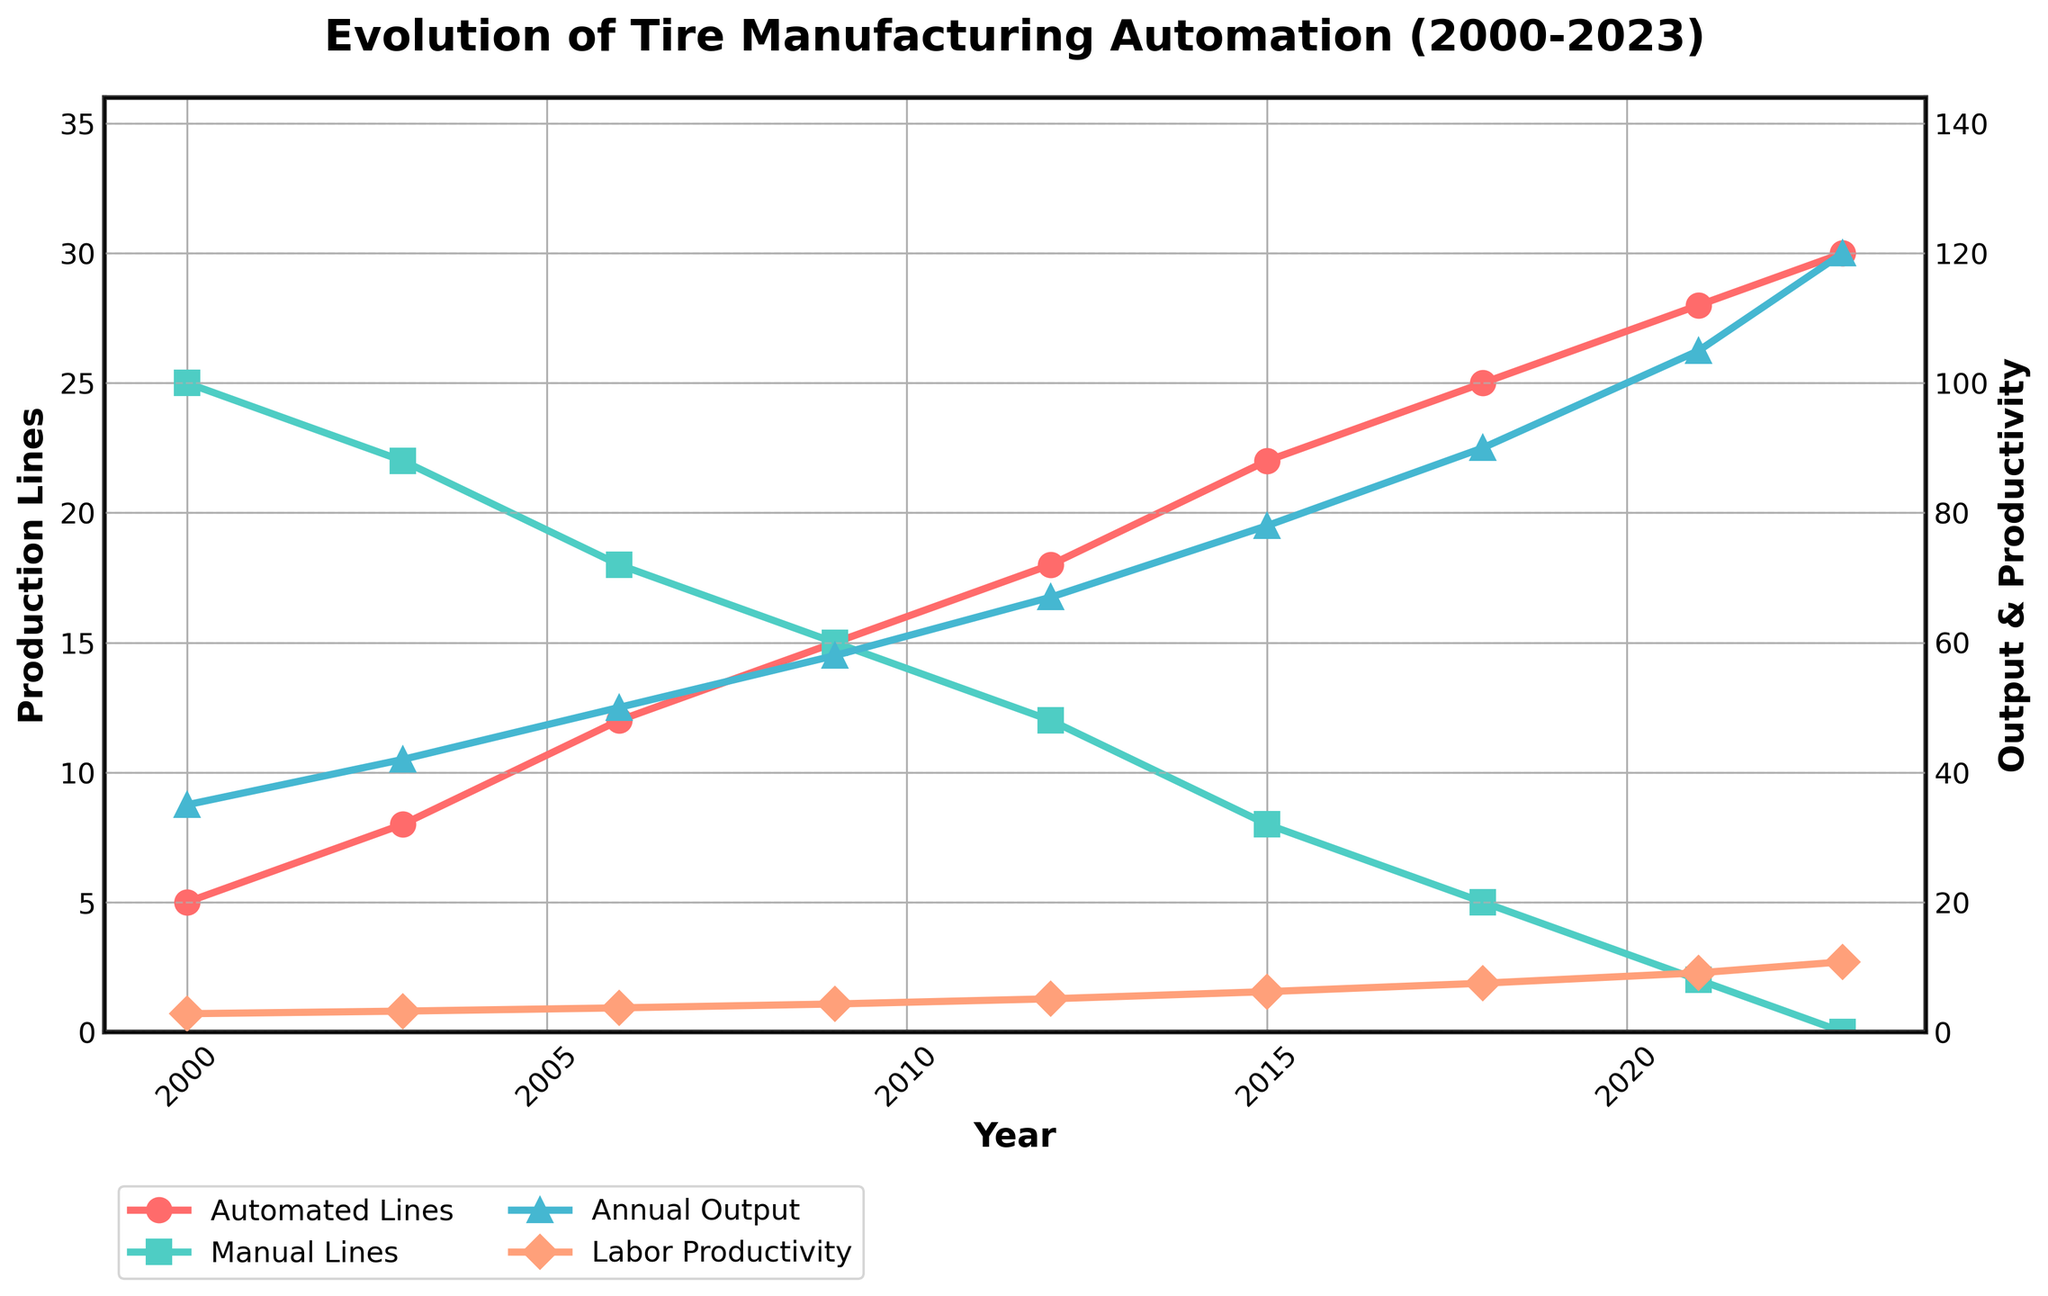What's the trend in the number of automated production lines from 2000 to 2023? The figure shows the number of automated production lines plotted across the years. Observing the red line, it consistently increases from 5 in 2000 to 30 in 2023.
Answer: Increasing How does the total annual output in 2023 compare to that in 2000? The blue line representing total annual output shows that it increases from 35 million units in 2000 to 120 million units in 2023.
Answer: Increased What relationship can you observe between the number of manual production lines and automated production lines over the years? The figure indicates that as the number of green manual production lines decreases, the number of red automated production lines increases, implying an inverse relationship.
Answer: Inverse relationship What is the defect rate in 2006 compared to 2023? In 2006, the defect rate is shown to be 1.1% and it decreases to 0.4% in 2023.
Answer: Decreased Which year shows the highest increase in labor productivity? By looking at the orange line representing labor productivity, we can see the sharpest increase occurs between 2018 and 2021, where it goes from 7.5 to 9.1 units per worker-hour.
Answer: 2021 How has the energy efficiency of tire manufacturing changed from 2000 to 2023? Observing the black line for energy efficiency, it improves, decreasing from 12.5 kWh per tire in 2000 to 7.3 kWh per tire in 2023.
Answer: Improved Calculate the average number of automated production lines from 2000 to 2023. Sum the data points for automated production lines: (5 + 8 + 12 + 15 + 18 + 22 + 25 + 28 + 30) = 163. Divide by the number of data points, which is 9. The average is 163 / 9 ≈ 18.1.
Answer: 18.1 Compare the total annual output and labor productivity in 2012. In 2012, the total annual output is 67 million units, while labor productivity is 5.1 units per worker-hour.
Answer: Output: 67 million, Productivity: 5.1 What was the difference in manual production lines between 2003 and 2015? In 2003, there were 22 manual production lines, and in 2015, there were 8. The difference is 22 - 8 = 14.
Answer: 14 What trend can be observed regarding labor productivity and defect rate correlation? As labor productivity (orange line) increases, the defect rate (pink line) consistently decreases, indicating a negative correlation.
Answer: Negative correlation 